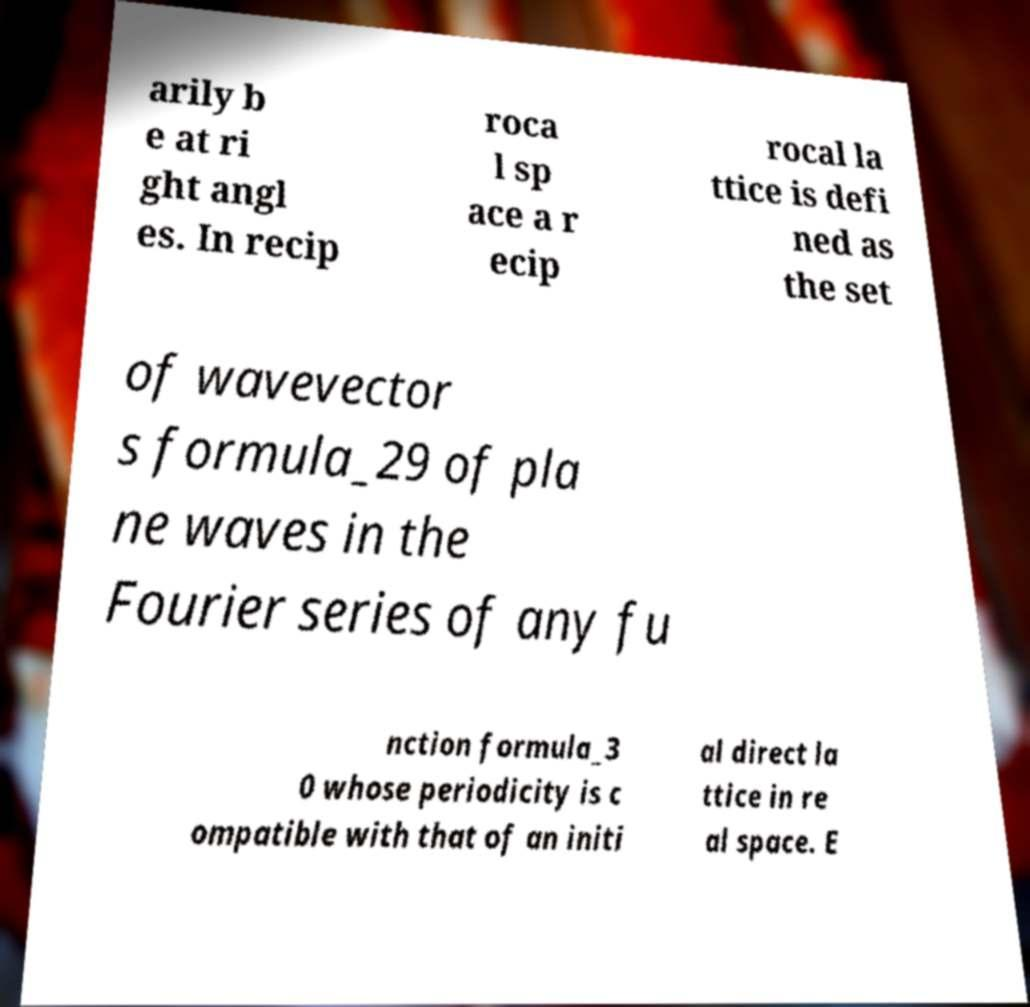Could you extract and type out the text from this image? arily b e at ri ght angl es. In recip roca l sp ace a r ecip rocal la ttice is defi ned as the set of wavevector s formula_29 of pla ne waves in the Fourier series of any fu nction formula_3 0 whose periodicity is c ompatible with that of an initi al direct la ttice in re al space. E 